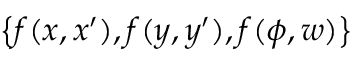<formula> <loc_0><loc_0><loc_500><loc_500>\left \{ { f ( x , x ^ { \prime } ) , f ( y , y ^ { \prime } ) , f ( \phi , w ) } \right \}</formula> 